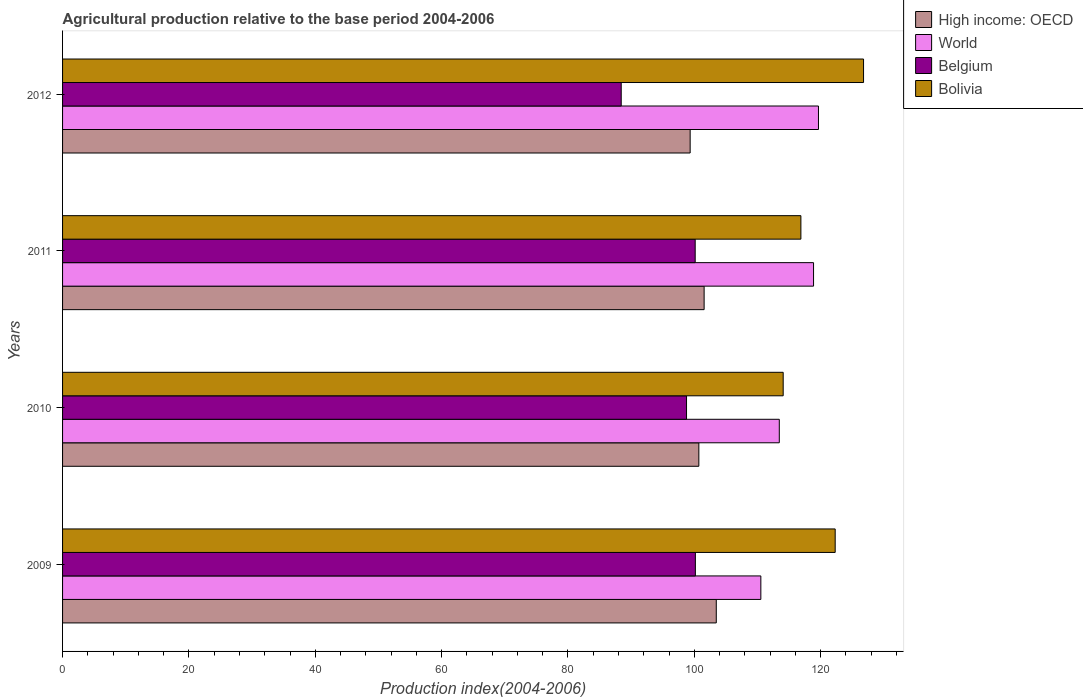How many different coloured bars are there?
Your answer should be compact. 4. How many groups of bars are there?
Your response must be concise. 4. Are the number of bars per tick equal to the number of legend labels?
Give a very brief answer. Yes. How many bars are there on the 3rd tick from the bottom?
Give a very brief answer. 4. What is the label of the 2nd group of bars from the top?
Make the answer very short. 2011. What is the agricultural production index in High income: OECD in 2010?
Keep it short and to the point. 100.72. Across all years, what is the maximum agricultural production index in Belgium?
Your response must be concise. 100.17. Across all years, what is the minimum agricultural production index in High income: OECD?
Ensure brevity in your answer.  99.34. In which year was the agricultural production index in Belgium maximum?
Your answer should be very brief. 2009. What is the total agricultural production index in World in the graph?
Offer a very short reply. 462.51. What is the difference between the agricultural production index in World in 2009 and that in 2011?
Offer a very short reply. -8.34. What is the difference between the agricultural production index in Bolivia in 2009 and the agricultural production index in Belgium in 2011?
Your answer should be very brief. 22.16. What is the average agricultural production index in World per year?
Provide a short and direct response. 115.63. In the year 2011, what is the difference between the agricultural production index in World and agricultural production index in Bolivia?
Your answer should be very brief. 2.01. What is the ratio of the agricultural production index in World in 2010 to that in 2011?
Keep it short and to the point. 0.95. What is the difference between the highest and the second highest agricultural production index in High income: OECD?
Offer a very short reply. 1.92. What is the difference between the highest and the lowest agricultural production index in World?
Your response must be concise. 9.12. In how many years, is the agricultural production index in High income: OECD greater than the average agricultural production index in High income: OECD taken over all years?
Give a very brief answer. 2. Is the sum of the agricultural production index in Bolivia in 2010 and 2012 greater than the maximum agricultural production index in Belgium across all years?
Your answer should be very brief. Yes. Is it the case that in every year, the sum of the agricultural production index in Bolivia and agricultural production index in High income: OECD is greater than the sum of agricultural production index in World and agricultural production index in Belgium?
Provide a succinct answer. No. What does the 1st bar from the top in 2010 represents?
Provide a short and direct response. Bolivia. Is it the case that in every year, the sum of the agricultural production index in World and agricultural production index in Bolivia is greater than the agricultural production index in Belgium?
Offer a very short reply. Yes. How many bars are there?
Make the answer very short. 16. Are the values on the major ticks of X-axis written in scientific E-notation?
Offer a terse response. No. How many legend labels are there?
Your response must be concise. 4. How are the legend labels stacked?
Your response must be concise. Vertical. What is the title of the graph?
Offer a terse response. Agricultural production relative to the base period 2004-2006. Does "Lithuania" appear as one of the legend labels in the graph?
Your response must be concise. No. What is the label or title of the X-axis?
Your answer should be very brief. Production index(2004-2006). What is the Production index(2004-2006) in High income: OECD in 2009?
Give a very brief answer. 103.48. What is the Production index(2004-2006) of World in 2009?
Provide a succinct answer. 110.53. What is the Production index(2004-2006) in Belgium in 2009?
Your response must be concise. 100.17. What is the Production index(2004-2006) in Bolivia in 2009?
Your answer should be very brief. 122.3. What is the Production index(2004-2006) of High income: OECD in 2010?
Provide a succinct answer. 100.72. What is the Production index(2004-2006) of World in 2010?
Give a very brief answer. 113.45. What is the Production index(2004-2006) of Belgium in 2010?
Give a very brief answer. 98.77. What is the Production index(2004-2006) in Bolivia in 2010?
Your response must be concise. 114.07. What is the Production index(2004-2006) of High income: OECD in 2011?
Give a very brief answer. 101.55. What is the Production index(2004-2006) in World in 2011?
Give a very brief answer. 118.88. What is the Production index(2004-2006) of Belgium in 2011?
Provide a short and direct response. 100.14. What is the Production index(2004-2006) of Bolivia in 2011?
Ensure brevity in your answer.  116.87. What is the Production index(2004-2006) of High income: OECD in 2012?
Keep it short and to the point. 99.34. What is the Production index(2004-2006) of World in 2012?
Your answer should be very brief. 119.65. What is the Production index(2004-2006) in Belgium in 2012?
Offer a very short reply. 88.43. What is the Production index(2004-2006) in Bolivia in 2012?
Give a very brief answer. 126.79. Across all years, what is the maximum Production index(2004-2006) of High income: OECD?
Your answer should be very brief. 103.48. Across all years, what is the maximum Production index(2004-2006) of World?
Provide a succinct answer. 119.65. Across all years, what is the maximum Production index(2004-2006) in Belgium?
Provide a short and direct response. 100.17. Across all years, what is the maximum Production index(2004-2006) of Bolivia?
Your answer should be compact. 126.79. Across all years, what is the minimum Production index(2004-2006) of High income: OECD?
Give a very brief answer. 99.34. Across all years, what is the minimum Production index(2004-2006) of World?
Make the answer very short. 110.53. Across all years, what is the minimum Production index(2004-2006) in Belgium?
Make the answer very short. 88.43. Across all years, what is the minimum Production index(2004-2006) in Bolivia?
Keep it short and to the point. 114.07. What is the total Production index(2004-2006) in High income: OECD in the graph?
Offer a terse response. 405.09. What is the total Production index(2004-2006) of World in the graph?
Your answer should be very brief. 462.51. What is the total Production index(2004-2006) of Belgium in the graph?
Give a very brief answer. 387.51. What is the total Production index(2004-2006) in Bolivia in the graph?
Your answer should be compact. 480.03. What is the difference between the Production index(2004-2006) in High income: OECD in 2009 and that in 2010?
Your answer should be very brief. 2.76. What is the difference between the Production index(2004-2006) in World in 2009 and that in 2010?
Offer a very short reply. -2.92. What is the difference between the Production index(2004-2006) in Belgium in 2009 and that in 2010?
Keep it short and to the point. 1.4. What is the difference between the Production index(2004-2006) of Bolivia in 2009 and that in 2010?
Your answer should be very brief. 8.23. What is the difference between the Production index(2004-2006) in High income: OECD in 2009 and that in 2011?
Your answer should be compact. 1.92. What is the difference between the Production index(2004-2006) in World in 2009 and that in 2011?
Give a very brief answer. -8.34. What is the difference between the Production index(2004-2006) of Bolivia in 2009 and that in 2011?
Your response must be concise. 5.43. What is the difference between the Production index(2004-2006) in High income: OECD in 2009 and that in 2012?
Offer a very short reply. 4.14. What is the difference between the Production index(2004-2006) of World in 2009 and that in 2012?
Give a very brief answer. -9.12. What is the difference between the Production index(2004-2006) in Belgium in 2009 and that in 2012?
Provide a succinct answer. 11.74. What is the difference between the Production index(2004-2006) of Bolivia in 2009 and that in 2012?
Offer a terse response. -4.49. What is the difference between the Production index(2004-2006) of High income: OECD in 2010 and that in 2011?
Provide a short and direct response. -0.83. What is the difference between the Production index(2004-2006) in World in 2010 and that in 2011?
Give a very brief answer. -5.42. What is the difference between the Production index(2004-2006) in Belgium in 2010 and that in 2011?
Give a very brief answer. -1.37. What is the difference between the Production index(2004-2006) of Bolivia in 2010 and that in 2011?
Your response must be concise. -2.8. What is the difference between the Production index(2004-2006) of High income: OECD in 2010 and that in 2012?
Provide a succinct answer. 1.38. What is the difference between the Production index(2004-2006) of World in 2010 and that in 2012?
Provide a succinct answer. -6.2. What is the difference between the Production index(2004-2006) in Belgium in 2010 and that in 2012?
Ensure brevity in your answer.  10.34. What is the difference between the Production index(2004-2006) of Bolivia in 2010 and that in 2012?
Offer a terse response. -12.72. What is the difference between the Production index(2004-2006) in High income: OECD in 2011 and that in 2012?
Offer a terse response. 2.21. What is the difference between the Production index(2004-2006) in World in 2011 and that in 2012?
Your response must be concise. -0.78. What is the difference between the Production index(2004-2006) in Belgium in 2011 and that in 2012?
Your response must be concise. 11.71. What is the difference between the Production index(2004-2006) in Bolivia in 2011 and that in 2012?
Ensure brevity in your answer.  -9.92. What is the difference between the Production index(2004-2006) of High income: OECD in 2009 and the Production index(2004-2006) of World in 2010?
Provide a short and direct response. -9.97. What is the difference between the Production index(2004-2006) of High income: OECD in 2009 and the Production index(2004-2006) of Belgium in 2010?
Your answer should be very brief. 4.71. What is the difference between the Production index(2004-2006) of High income: OECD in 2009 and the Production index(2004-2006) of Bolivia in 2010?
Give a very brief answer. -10.59. What is the difference between the Production index(2004-2006) of World in 2009 and the Production index(2004-2006) of Belgium in 2010?
Keep it short and to the point. 11.76. What is the difference between the Production index(2004-2006) in World in 2009 and the Production index(2004-2006) in Bolivia in 2010?
Your answer should be very brief. -3.54. What is the difference between the Production index(2004-2006) in High income: OECD in 2009 and the Production index(2004-2006) in World in 2011?
Give a very brief answer. -15.4. What is the difference between the Production index(2004-2006) of High income: OECD in 2009 and the Production index(2004-2006) of Belgium in 2011?
Make the answer very short. 3.34. What is the difference between the Production index(2004-2006) in High income: OECD in 2009 and the Production index(2004-2006) in Bolivia in 2011?
Your answer should be compact. -13.39. What is the difference between the Production index(2004-2006) of World in 2009 and the Production index(2004-2006) of Belgium in 2011?
Provide a short and direct response. 10.39. What is the difference between the Production index(2004-2006) in World in 2009 and the Production index(2004-2006) in Bolivia in 2011?
Keep it short and to the point. -6.34. What is the difference between the Production index(2004-2006) of Belgium in 2009 and the Production index(2004-2006) of Bolivia in 2011?
Your answer should be compact. -16.7. What is the difference between the Production index(2004-2006) in High income: OECD in 2009 and the Production index(2004-2006) in World in 2012?
Your answer should be compact. -16.18. What is the difference between the Production index(2004-2006) in High income: OECD in 2009 and the Production index(2004-2006) in Belgium in 2012?
Offer a terse response. 15.05. What is the difference between the Production index(2004-2006) in High income: OECD in 2009 and the Production index(2004-2006) in Bolivia in 2012?
Keep it short and to the point. -23.31. What is the difference between the Production index(2004-2006) in World in 2009 and the Production index(2004-2006) in Belgium in 2012?
Your answer should be very brief. 22.1. What is the difference between the Production index(2004-2006) in World in 2009 and the Production index(2004-2006) in Bolivia in 2012?
Your answer should be very brief. -16.26. What is the difference between the Production index(2004-2006) in Belgium in 2009 and the Production index(2004-2006) in Bolivia in 2012?
Offer a very short reply. -26.62. What is the difference between the Production index(2004-2006) of High income: OECD in 2010 and the Production index(2004-2006) of World in 2011?
Make the answer very short. -18.16. What is the difference between the Production index(2004-2006) in High income: OECD in 2010 and the Production index(2004-2006) in Belgium in 2011?
Offer a terse response. 0.58. What is the difference between the Production index(2004-2006) in High income: OECD in 2010 and the Production index(2004-2006) in Bolivia in 2011?
Your answer should be compact. -16.15. What is the difference between the Production index(2004-2006) of World in 2010 and the Production index(2004-2006) of Belgium in 2011?
Offer a terse response. 13.31. What is the difference between the Production index(2004-2006) in World in 2010 and the Production index(2004-2006) in Bolivia in 2011?
Offer a terse response. -3.42. What is the difference between the Production index(2004-2006) of Belgium in 2010 and the Production index(2004-2006) of Bolivia in 2011?
Your answer should be very brief. -18.1. What is the difference between the Production index(2004-2006) of High income: OECD in 2010 and the Production index(2004-2006) of World in 2012?
Offer a very short reply. -18.94. What is the difference between the Production index(2004-2006) of High income: OECD in 2010 and the Production index(2004-2006) of Belgium in 2012?
Your response must be concise. 12.29. What is the difference between the Production index(2004-2006) in High income: OECD in 2010 and the Production index(2004-2006) in Bolivia in 2012?
Your answer should be compact. -26.07. What is the difference between the Production index(2004-2006) of World in 2010 and the Production index(2004-2006) of Belgium in 2012?
Give a very brief answer. 25.02. What is the difference between the Production index(2004-2006) of World in 2010 and the Production index(2004-2006) of Bolivia in 2012?
Your response must be concise. -13.34. What is the difference between the Production index(2004-2006) of Belgium in 2010 and the Production index(2004-2006) of Bolivia in 2012?
Keep it short and to the point. -28.02. What is the difference between the Production index(2004-2006) of High income: OECD in 2011 and the Production index(2004-2006) of World in 2012?
Offer a terse response. -18.1. What is the difference between the Production index(2004-2006) of High income: OECD in 2011 and the Production index(2004-2006) of Belgium in 2012?
Provide a succinct answer. 13.12. What is the difference between the Production index(2004-2006) in High income: OECD in 2011 and the Production index(2004-2006) in Bolivia in 2012?
Give a very brief answer. -25.24. What is the difference between the Production index(2004-2006) in World in 2011 and the Production index(2004-2006) in Belgium in 2012?
Your answer should be very brief. 30.45. What is the difference between the Production index(2004-2006) of World in 2011 and the Production index(2004-2006) of Bolivia in 2012?
Your answer should be very brief. -7.91. What is the difference between the Production index(2004-2006) of Belgium in 2011 and the Production index(2004-2006) of Bolivia in 2012?
Your answer should be compact. -26.65. What is the average Production index(2004-2006) of High income: OECD per year?
Keep it short and to the point. 101.27. What is the average Production index(2004-2006) in World per year?
Offer a terse response. 115.63. What is the average Production index(2004-2006) in Belgium per year?
Offer a very short reply. 96.88. What is the average Production index(2004-2006) in Bolivia per year?
Your answer should be compact. 120.01. In the year 2009, what is the difference between the Production index(2004-2006) in High income: OECD and Production index(2004-2006) in World?
Offer a very short reply. -7.05. In the year 2009, what is the difference between the Production index(2004-2006) of High income: OECD and Production index(2004-2006) of Belgium?
Ensure brevity in your answer.  3.31. In the year 2009, what is the difference between the Production index(2004-2006) in High income: OECD and Production index(2004-2006) in Bolivia?
Your answer should be very brief. -18.82. In the year 2009, what is the difference between the Production index(2004-2006) in World and Production index(2004-2006) in Belgium?
Ensure brevity in your answer.  10.36. In the year 2009, what is the difference between the Production index(2004-2006) of World and Production index(2004-2006) of Bolivia?
Ensure brevity in your answer.  -11.77. In the year 2009, what is the difference between the Production index(2004-2006) of Belgium and Production index(2004-2006) of Bolivia?
Your response must be concise. -22.13. In the year 2010, what is the difference between the Production index(2004-2006) of High income: OECD and Production index(2004-2006) of World?
Keep it short and to the point. -12.73. In the year 2010, what is the difference between the Production index(2004-2006) of High income: OECD and Production index(2004-2006) of Belgium?
Provide a succinct answer. 1.95. In the year 2010, what is the difference between the Production index(2004-2006) in High income: OECD and Production index(2004-2006) in Bolivia?
Provide a succinct answer. -13.35. In the year 2010, what is the difference between the Production index(2004-2006) of World and Production index(2004-2006) of Belgium?
Provide a short and direct response. 14.68. In the year 2010, what is the difference between the Production index(2004-2006) in World and Production index(2004-2006) in Bolivia?
Offer a terse response. -0.62. In the year 2010, what is the difference between the Production index(2004-2006) in Belgium and Production index(2004-2006) in Bolivia?
Provide a short and direct response. -15.3. In the year 2011, what is the difference between the Production index(2004-2006) of High income: OECD and Production index(2004-2006) of World?
Provide a short and direct response. -17.32. In the year 2011, what is the difference between the Production index(2004-2006) of High income: OECD and Production index(2004-2006) of Belgium?
Provide a succinct answer. 1.41. In the year 2011, what is the difference between the Production index(2004-2006) of High income: OECD and Production index(2004-2006) of Bolivia?
Provide a succinct answer. -15.32. In the year 2011, what is the difference between the Production index(2004-2006) of World and Production index(2004-2006) of Belgium?
Your response must be concise. 18.74. In the year 2011, what is the difference between the Production index(2004-2006) of World and Production index(2004-2006) of Bolivia?
Keep it short and to the point. 2.01. In the year 2011, what is the difference between the Production index(2004-2006) of Belgium and Production index(2004-2006) of Bolivia?
Your response must be concise. -16.73. In the year 2012, what is the difference between the Production index(2004-2006) in High income: OECD and Production index(2004-2006) in World?
Provide a succinct answer. -20.31. In the year 2012, what is the difference between the Production index(2004-2006) of High income: OECD and Production index(2004-2006) of Belgium?
Ensure brevity in your answer.  10.91. In the year 2012, what is the difference between the Production index(2004-2006) in High income: OECD and Production index(2004-2006) in Bolivia?
Ensure brevity in your answer.  -27.45. In the year 2012, what is the difference between the Production index(2004-2006) in World and Production index(2004-2006) in Belgium?
Make the answer very short. 31.22. In the year 2012, what is the difference between the Production index(2004-2006) of World and Production index(2004-2006) of Bolivia?
Make the answer very short. -7.14. In the year 2012, what is the difference between the Production index(2004-2006) in Belgium and Production index(2004-2006) in Bolivia?
Provide a short and direct response. -38.36. What is the ratio of the Production index(2004-2006) of High income: OECD in 2009 to that in 2010?
Your answer should be very brief. 1.03. What is the ratio of the Production index(2004-2006) of World in 2009 to that in 2010?
Ensure brevity in your answer.  0.97. What is the ratio of the Production index(2004-2006) of Belgium in 2009 to that in 2010?
Provide a short and direct response. 1.01. What is the ratio of the Production index(2004-2006) in Bolivia in 2009 to that in 2010?
Your response must be concise. 1.07. What is the ratio of the Production index(2004-2006) of High income: OECD in 2009 to that in 2011?
Your response must be concise. 1.02. What is the ratio of the Production index(2004-2006) in World in 2009 to that in 2011?
Make the answer very short. 0.93. What is the ratio of the Production index(2004-2006) of Bolivia in 2009 to that in 2011?
Your answer should be very brief. 1.05. What is the ratio of the Production index(2004-2006) in High income: OECD in 2009 to that in 2012?
Your answer should be very brief. 1.04. What is the ratio of the Production index(2004-2006) of World in 2009 to that in 2012?
Your answer should be compact. 0.92. What is the ratio of the Production index(2004-2006) in Belgium in 2009 to that in 2012?
Offer a terse response. 1.13. What is the ratio of the Production index(2004-2006) in Bolivia in 2009 to that in 2012?
Your answer should be compact. 0.96. What is the ratio of the Production index(2004-2006) of World in 2010 to that in 2011?
Offer a terse response. 0.95. What is the ratio of the Production index(2004-2006) in Belgium in 2010 to that in 2011?
Your response must be concise. 0.99. What is the ratio of the Production index(2004-2006) in High income: OECD in 2010 to that in 2012?
Keep it short and to the point. 1.01. What is the ratio of the Production index(2004-2006) of World in 2010 to that in 2012?
Provide a short and direct response. 0.95. What is the ratio of the Production index(2004-2006) of Belgium in 2010 to that in 2012?
Ensure brevity in your answer.  1.12. What is the ratio of the Production index(2004-2006) in Bolivia in 2010 to that in 2012?
Keep it short and to the point. 0.9. What is the ratio of the Production index(2004-2006) in High income: OECD in 2011 to that in 2012?
Give a very brief answer. 1.02. What is the ratio of the Production index(2004-2006) of World in 2011 to that in 2012?
Provide a short and direct response. 0.99. What is the ratio of the Production index(2004-2006) of Belgium in 2011 to that in 2012?
Make the answer very short. 1.13. What is the ratio of the Production index(2004-2006) in Bolivia in 2011 to that in 2012?
Keep it short and to the point. 0.92. What is the difference between the highest and the second highest Production index(2004-2006) of High income: OECD?
Offer a very short reply. 1.92. What is the difference between the highest and the second highest Production index(2004-2006) in World?
Make the answer very short. 0.78. What is the difference between the highest and the second highest Production index(2004-2006) of Belgium?
Give a very brief answer. 0.03. What is the difference between the highest and the second highest Production index(2004-2006) of Bolivia?
Your response must be concise. 4.49. What is the difference between the highest and the lowest Production index(2004-2006) of High income: OECD?
Ensure brevity in your answer.  4.14. What is the difference between the highest and the lowest Production index(2004-2006) in World?
Provide a short and direct response. 9.12. What is the difference between the highest and the lowest Production index(2004-2006) in Belgium?
Your answer should be very brief. 11.74. What is the difference between the highest and the lowest Production index(2004-2006) in Bolivia?
Keep it short and to the point. 12.72. 